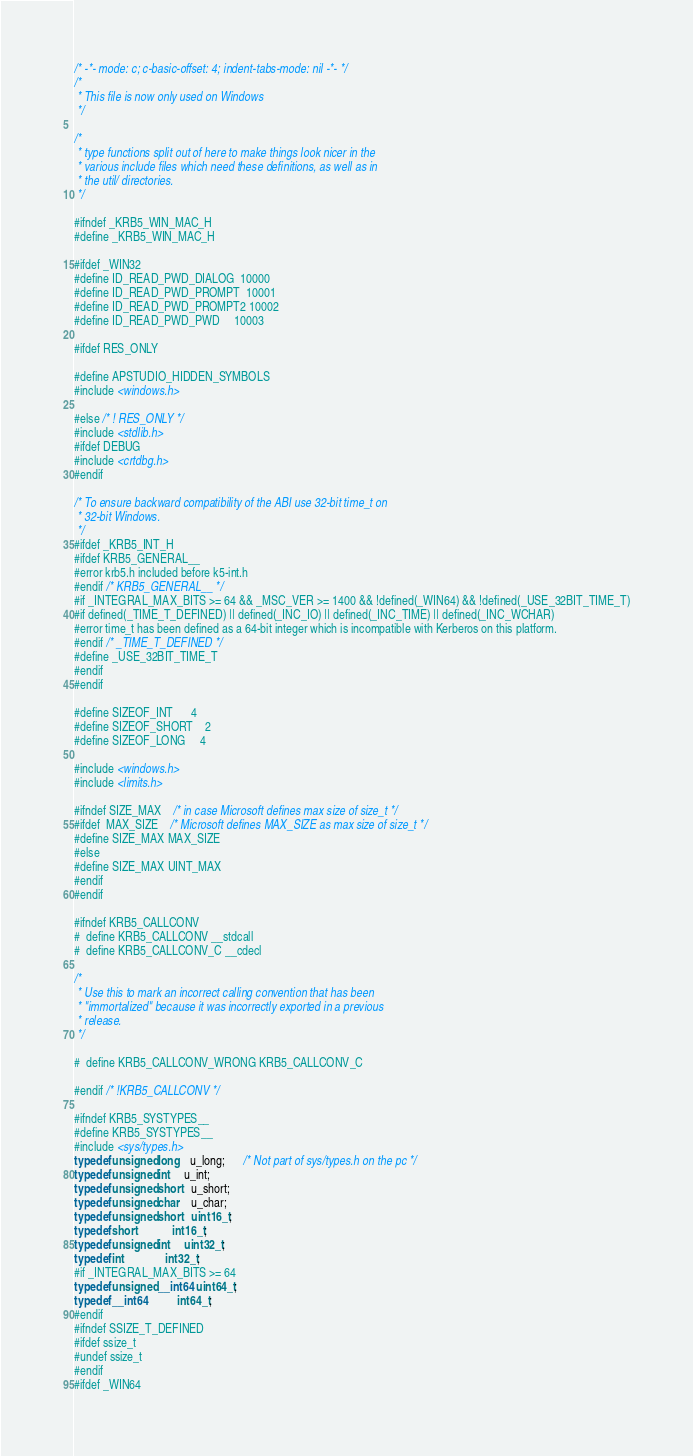<code> <loc_0><loc_0><loc_500><loc_500><_C_>/* -*- mode: c; c-basic-offset: 4; indent-tabs-mode: nil -*- */
/*
 * This file is now only used on Windows
 */

/*
 * type functions split out of here to make things look nicer in the
 * various include files which need these definitions, as well as in
 * the util/ directories.
 */

#ifndef _KRB5_WIN_MAC_H
#define _KRB5_WIN_MAC_H

#ifdef _WIN32
#define ID_READ_PWD_DIALOG  10000
#define ID_READ_PWD_PROMPT  10001
#define ID_READ_PWD_PROMPT2 10002
#define ID_READ_PWD_PWD     10003

#ifdef RES_ONLY

#define APSTUDIO_HIDDEN_SYMBOLS
#include <windows.h>

#else /* ! RES_ONLY */
#include <stdlib.h>
#ifdef DEBUG
#include <crtdbg.h>
#endif

/* To ensure backward compatibility of the ABI use 32-bit time_t on
 * 32-bit Windows.
 */
#ifdef _KRB5_INT_H
#ifdef KRB5_GENERAL__
#error krb5.h included before k5-int.h
#endif /* KRB5_GENERAL__ */
#if _INTEGRAL_MAX_BITS >= 64 && _MSC_VER >= 1400 && !defined(_WIN64) && !defined(_USE_32BIT_TIME_T)
#if defined(_TIME_T_DEFINED) || defined(_INC_IO) || defined(_INC_TIME) || defined(_INC_WCHAR)
#error time_t has been defined as a 64-bit integer which is incompatible with Kerberos on this platform.
#endif /* _TIME_T_DEFINED */
#define _USE_32BIT_TIME_T
#endif
#endif

#define SIZEOF_INT      4
#define SIZEOF_SHORT    2
#define SIZEOF_LONG     4

#include <windows.h>
#include <limits.h>

#ifndef SIZE_MAX    /* in case Microsoft defines max size of size_t */
#ifdef  MAX_SIZE    /* Microsoft defines MAX_SIZE as max size of size_t */
#define SIZE_MAX MAX_SIZE
#else
#define SIZE_MAX UINT_MAX
#endif
#endif

#ifndef KRB5_CALLCONV
#  define KRB5_CALLCONV __stdcall
#  define KRB5_CALLCONV_C __cdecl

/*
 * Use this to mark an incorrect calling convention that has been
 * "immortalized" because it was incorrectly exported in a previous
 * release.
 */

#  define KRB5_CALLCONV_WRONG KRB5_CALLCONV_C

#endif /* !KRB5_CALLCONV */

#ifndef KRB5_SYSTYPES__
#define KRB5_SYSTYPES__
#include <sys/types.h>
typedef unsigned long    u_long;      /* Not part of sys/types.h on the pc */
typedef unsigned int     u_int;
typedef unsigned short   u_short;
typedef unsigned char    u_char;
typedef unsigned short   uint16_t;
typedef short            int16_t;
typedef unsigned int     uint32_t;
typedef int              int32_t;
#if _INTEGRAL_MAX_BITS >= 64
typedef unsigned __int64 uint64_t;
typedef __int64          int64_t;
#endif
#ifndef SSIZE_T_DEFINED
#ifdef ssize_t
#undef ssize_t
#endif
#ifdef _WIN64</code> 